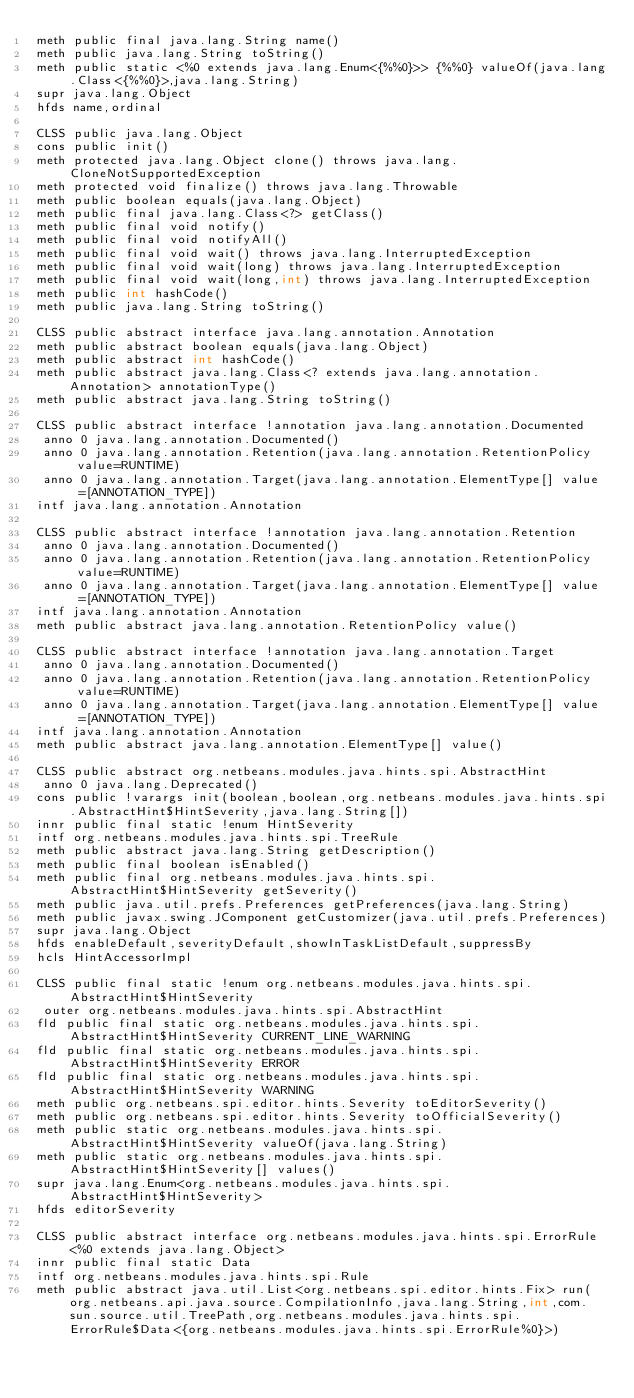Convert code to text. <code><loc_0><loc_0><loc_500><loc_500><_SML_>meth public final java.lang.String name()
meth public java.lang.String toString()
meth public static <%0 extends java.lang.Enum<{%%0}>> {%%0} valueOf(java.lang.Class<{%%0}>,java.lang.String)
supr java.lang.Object
hfds name,ordinal

CLSS public java.lang.Object
cons public init()
meth protected java.lang.Object clone() throws java.lang.CloneNotSupportedException
meth protected void finalize() throws java.lang.Throwable
meth public boolean equals(java.lang.Object)
meth public final java.lang.Class<?> getClass()
meth public final void notify()
meth public final void notifyAll()
meth public final void wait() throws java.lang.InterruptedException
meth public final void wait(long) throws java.lang.InterruptedException
meth public final void wait(long,int) throws java.lang.InterruptedException
meth public int hashCode()
meth public java.lang.String toString()

CLSS public abstract interface java.lang.annotation.Annotation
meth public abstract boolean equals(java.lang.Object)
meth public abstract int hashCode()
meth public abstract java.lang.Class<? extends java.lang.annotation.Annotation> annotationType()
meth public abstract java.lang.String toString()

CLSS public abstract interface !annotation java.lang.annotation.Documented
 anno 0 java.lang.annotation.Documented()
 anno 0 java.lang.annotation.Retention(java.lang.annotation.RetentionPolicy value=RUNTIME)
 anno 0 java.lang.annotation.Target(java.lang.annotation.ElementType[] value=[ANNOTATION_TYPE])
intf java.lang.annotation.Annotation

CLSS public abstract interface !annotation java.lang.annotation.Retention
 anno 0 java.lang.annotation.Documented()
 anno 0 java.lang.annotation.Retention(java.lang.annotation.RetentionPolicy value=RUNTIME)
 anno 0 java.lang.annotation.Target(java.lang.annotation.ElementType[] value=[ANNOTATION_TYPE])
intf java.lang.annotation.Annotation
meth public abstract java.lang.annotation.RetentionPolicy value()

CLSS public abstract interface !annotation java.lang.annotation.Target
 anno 0 java.lang.annotation.Documented()
 anno 0 java.lang.annotation.Retention(java.lang.annotation.RetentionPolicy value=RUNTIME)
 anno 0 java.lang.annotation.Target(java.lang.annotation.ElementType[] value=[ANNOTATION_TYPE])
intf java.lang.annotation.Annotation
meth public abstract java.lang.annotation.ElementType[] value()

CLSS public abstract org.netbeans.modules.java.hints.spi.AbstractHint
 anno 0 java.lang.Deprecated()
cons public !varargs init(boolean,boolean,org.netbeans.modules.java.hints.spi.AbstractHint$HintSeverity,java.lang.String[])
innr public final static !enum HintSeverity
intf org.netbeans.modules.java.hints.spi.TreeRule
meth public abstract java.lang.String getDescription()
meth public final boolean isEnabled()
meth public final org.netbeans.modules.java.hints.spi.AbstractHint$HintSeverity getSeverity()
meth public java.util.prefs.Preferences getPreferences(java.lang.String)
meth public javax.swing.JComponent getCustomizer(java.util.prefs.Preferences)
supr java.lang.Object
hfds enableDefault,severityDefault,showInTaskListDefault,suppressBy
hcls HintAccessorImpl

CLSS public final static !enum org.netbeans.modules.java.hints.spi.AbstractHint$HintSeverity
 outer org.netbeans.modules.java.hints.spi.AbstractHint
fld public final static org.netbeans.modules.java.hints.spi.AbstractHint$HintSeverity CURRENT_LINE_WARNING
fld public final static org.netbeans.modules.java.hints.spi.AbstractHint$HintSeverity ERROR
fld public final static org.netbeans.modules.java.hints.spi.AbstractHint$HintSeverity WARNING
meth public org.netbeans.spi.editor.hints.Severity toEditorSeverity()
meth public org.netbeans.spi.editor.hints.Severity toOfficialSeverity()
meth public static org.netbeans.modules.java.hints.spi.AbstractHint$HintSeverity valueOf(java.lang.String)
meth public static org.netbeans.modules.java.hints.spi.AbstractHint$HintSeverity[] values()
supr java.lang.Enum<org.netbeans.modules.java.hints.spi.AbstractHint$HintSeverity>
hfds editorSeverity

CLSS public abstract interface org.netbeans.modules.java.hints.spi.ErrorRule<%0 extends java.lang.Object>
innr public final static Data
intf org.netbeans.modules.java.hints.spi.Rule
meth public abstract java.util.List<org.netbeans.spi.editor.hints.Fix> run(org.netbeans.api.java.source.CompilationInfo,java.lang.String,int,com.sun.source.util.TreePath,org.netbeans.modules.java.hints.spi.ErrorRule$Data<{org.netbeans.modules.java.hints.spi.ErrorRule%0}>)</code> 